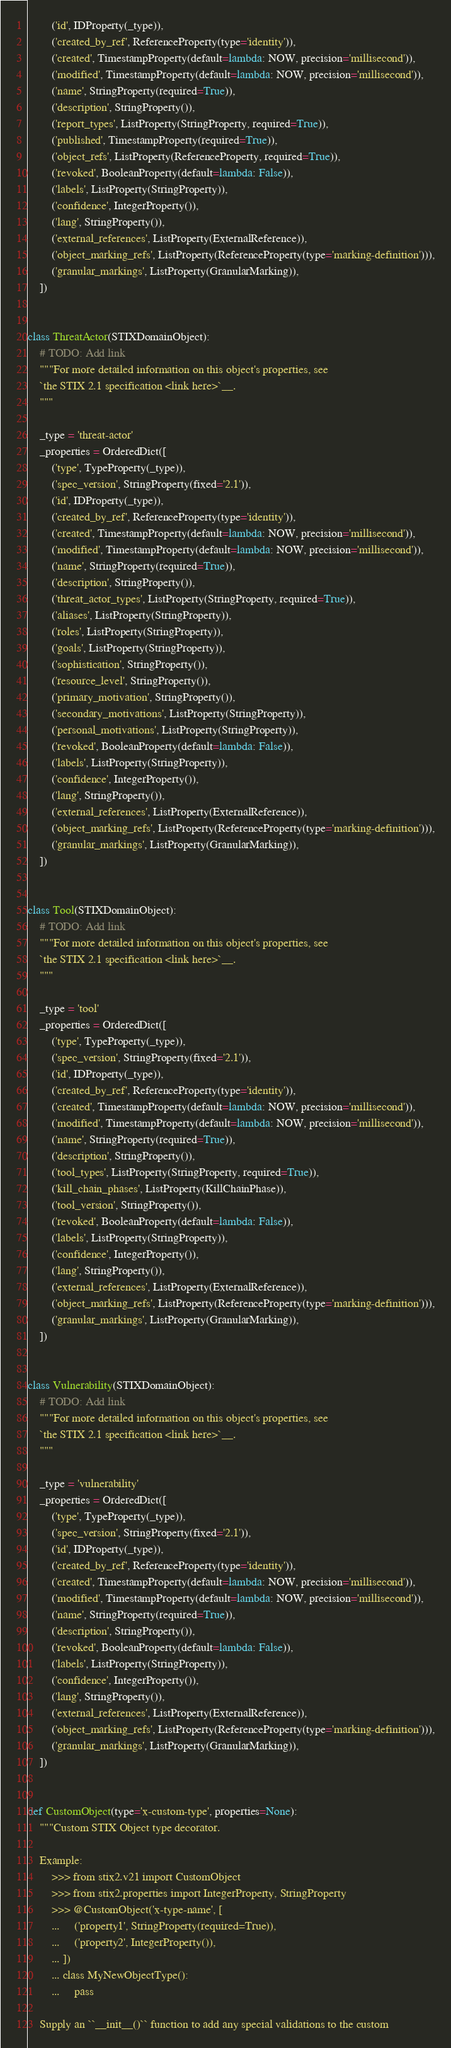<code> <loc_0><loc_0><loc_500><loc_500><_Python_>        ('id', IDProperty(_type)),
        ('created_by_ref', ReferenceProperty(type='identity')),
        ('created', TimestampProperty(default=lambda: NOW, precision='millisecond')),
        ('modified', TimestampProperty(default=lambda: NOW, precision='millisecond')),
        ('name', StringProperty(required=True)),
        ('description', StringProperty()),
        ('report_types', ListProperty(StringProperty, required=True)),
        ('published', TimestampProperty(required=True)),
        ('object_refs', ListProperty(ReferenceProperty, required=True)),
        ('revoked', BooleanProperty(default=lambda: False)),
        ('labels', ListProperty(StringProperty)),
        ('confidence', IntegerProperty()),
        ('lang', StringProperty()),
        ('external_references', ListProperty(ExternalReference)),
        ('object_marking_refs', ListProperty(ReferenceProperty(type='marking-definition'))),
        ('granular_markings', ListProperty(GranularMarking)),
    ])


class ThreatActor(STIXDomainObject):
    # TODO: Add link
    """For more detailed information on this object's properties, see
    `the STIX 2.1 specification <link here>`__.
    """

    _type = 'threat-actor'
    _properties = OrderedDict([
        ('type', TypeProperty(_type)),
        ('spec_version', StringProperty(fixed='2.1')),
        ('id', IDProperty(_type)),
        ('created_by_ref', ReferenceProperty(type='identity')),
        ('created', TimestampProperty(default=lambda: NOW, precision='millisecond')),
        ('modified', TimestampProperty(default=lambda: NOW, precision='millisecond')),
        ('name', StringProperty(required=True)),
        ('description', StringProperty()),
        ('threat_actor_types', ListProperty(StringProperty, required=True)),
        ('aliases', ListProperty(StringProperty)),
        ('roles', ListProperty(StringProperty)),
        ('goals', ListProperty(StringProperty)),
        ('sophistication', StringProperty()),
        ('resource_level', StringProperty()),
        ('primary_motivation', StringProperty()),
        ('secondary_motivations', ListProperty(StringProperty)),
        ('personal_motivations', ListProperty(StringProperty)),
        ('revoked', BooleanProperty(default=lambda: False)),
        ('labels', ListProperty(StringProperty)),
        ('confidence', IntegerProperty()),
        ('lang', StringProperty()),
        ('external_references', ListProperty(ExternalReference)),
        ('object_marking_refs', ListProperty(ReferenceProperty(type='marking-definition'))),
        ('granular_markings', ListProperty(GranularMarking)),
    ])


class Tool(STIXDomainObject):
    # TODO: Add link
    """For more detailed information on this object's properties, see
    `the STIX 2.1 specification <link here>`__.
    """

    _type = 'tool'
    _properties = OrderedDict([
        ('type', TypeProperty(_type)),
        ('spec_version', StringProperty(fixed='2.1')),
        ('id', IDProperty(_type)),
        ('created_by_ref', ReferenceProperty(type='identity')),
        ('created', TimestampProperty(default=lambda: NOW, precision='millisecond')),
        ('modified', TimestampProperty(default=lambda: NOW, precision='millisecond')),
        ('name', StringProperty(required=True)),
        ('description', StringProperty()),
        ('tool_types', ListProperty(StringProperty, required=True)),
        ('kill_chain_phases', ListProperty(KillChainPhase)),
        ('tool_version', StringProperty()),
        ('revoked', BooleanProperty(default=lambda: False)),
        ('labels', ListProperty(StringProperty)),
        ('confidence', IntegerProperty()),
        ('lang', StringProperty()),
        ('external_references', ListProperty(ExternalReference)),
        ('object_marking_refs', ListProperty(ReferenceProperty(type='marking-definition'))),
        ('granular_markings', ListProperty(GranularMarking)),
    ])


class Vulnerability(STIXDomainObject):
    # TODO: Add link
    """For more detailed information on this object's properties, see
    `the STIX 2.1 specification <link here>`__.
    """

    _type = 'vulnerability'
    _properties = OrderedDict([
        ('type', TypeProperty(_type)),
        ('spec_version', StringProperty(fixed='2.1')),
        ('id', IDProperty(_type)),
        ('created_by_ref', ReferenceProperty(type='identity')),
        ('created', TimestampProperty(default=lambda: NOW, precision='millisecond')),
        ('modified', TimestampProperty(default=lambda: NOW, precision='millisecond')),
        ('name', StringProperty(required=True)),
        ('description', StringProperty()),
        ('revoked', BooleanProperty(default=lambda: False)),
        ('labels', ListProperty(StringProperty)),
        ('confidence', IntegerProperty()),
        ('lang', StringProperty()),
        ('external_references', ListProperty(ExternalReference)),
        ('object_marking_refs', ListProperty(ReferenceProperty(type='marking-definition'))),
        ('granular_markings', ListProperty(GranularMarking)),
    ])


def CustomObject(type='x-custom-type', properties=None):
    """Custom STIX Object type decorator.

    Example:
        >>> from stix2.v21 import CustomObject
        >>> from stix2.properties import IntegerProperty, StringProperty
        >>> @CustomObject('x-type-name', [
        ...     ('property1', StringProperty(required=True)),
        ...     ('property2', IntegerProperty()),
        ... ])
        ... class MyNewObjectType():
        ...     pass

    Supply an ``__init__()`` function to add any special validations to the custom</code> 